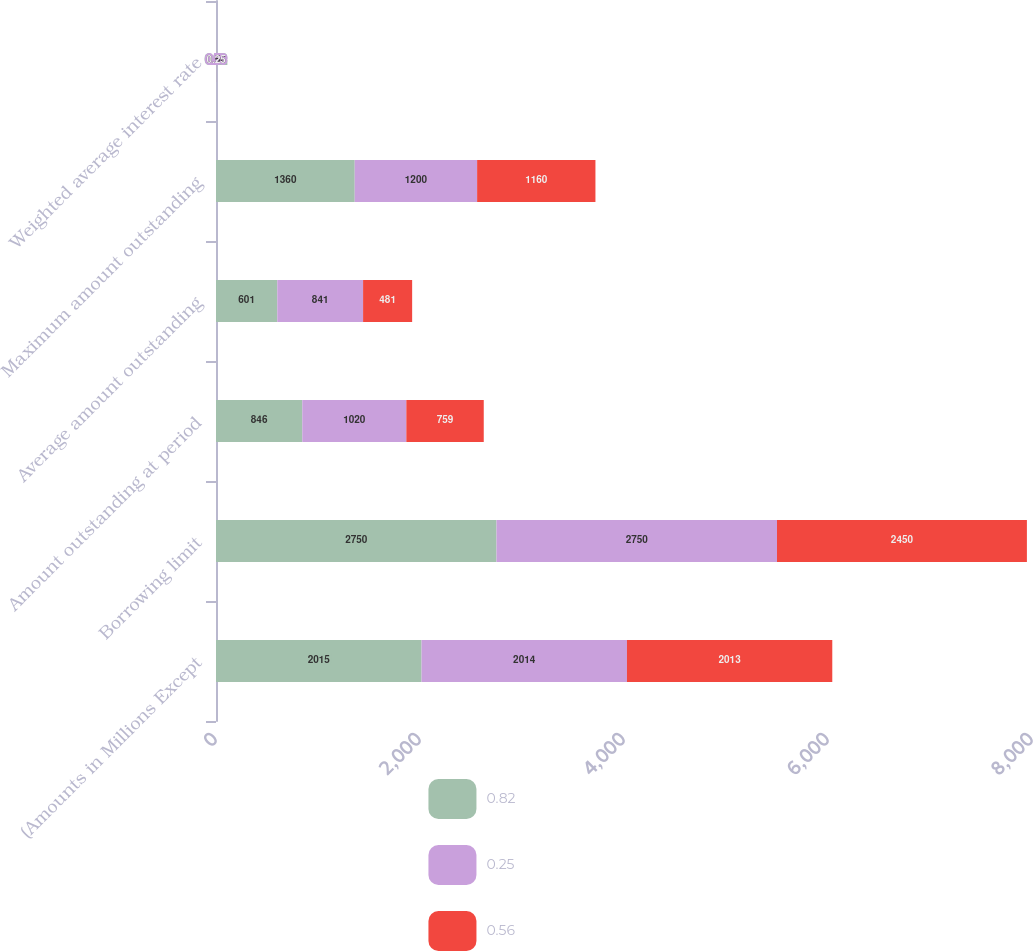Convert chart. <chart><loc_0><loc_0><loc_500><loc_500><stacked_bar_chart><ecel><fcel>(Amounts in Millions Except<fcel>Borrowing limit<fcel>Amount outstanding at period<fcel>Average amount outstanding<fcel>Maximum amount outstanding<fcel>Weighted average interest rate<nl><fcel>0.82<fcel>2015<fcel>2750<fcel>846<fcel>601<fcel>1360<fcel>0.82<nl><fcel>0.25<fcel>2014<fcel>2750<fcel>1020<fcel>841<fcel>1200<fcel>0.56<nl><fcel>0.56<fcel>2013<fcel>2450<fcel>759<fcel>481<fcel>1160<fcel>0.25<nl></chart> 